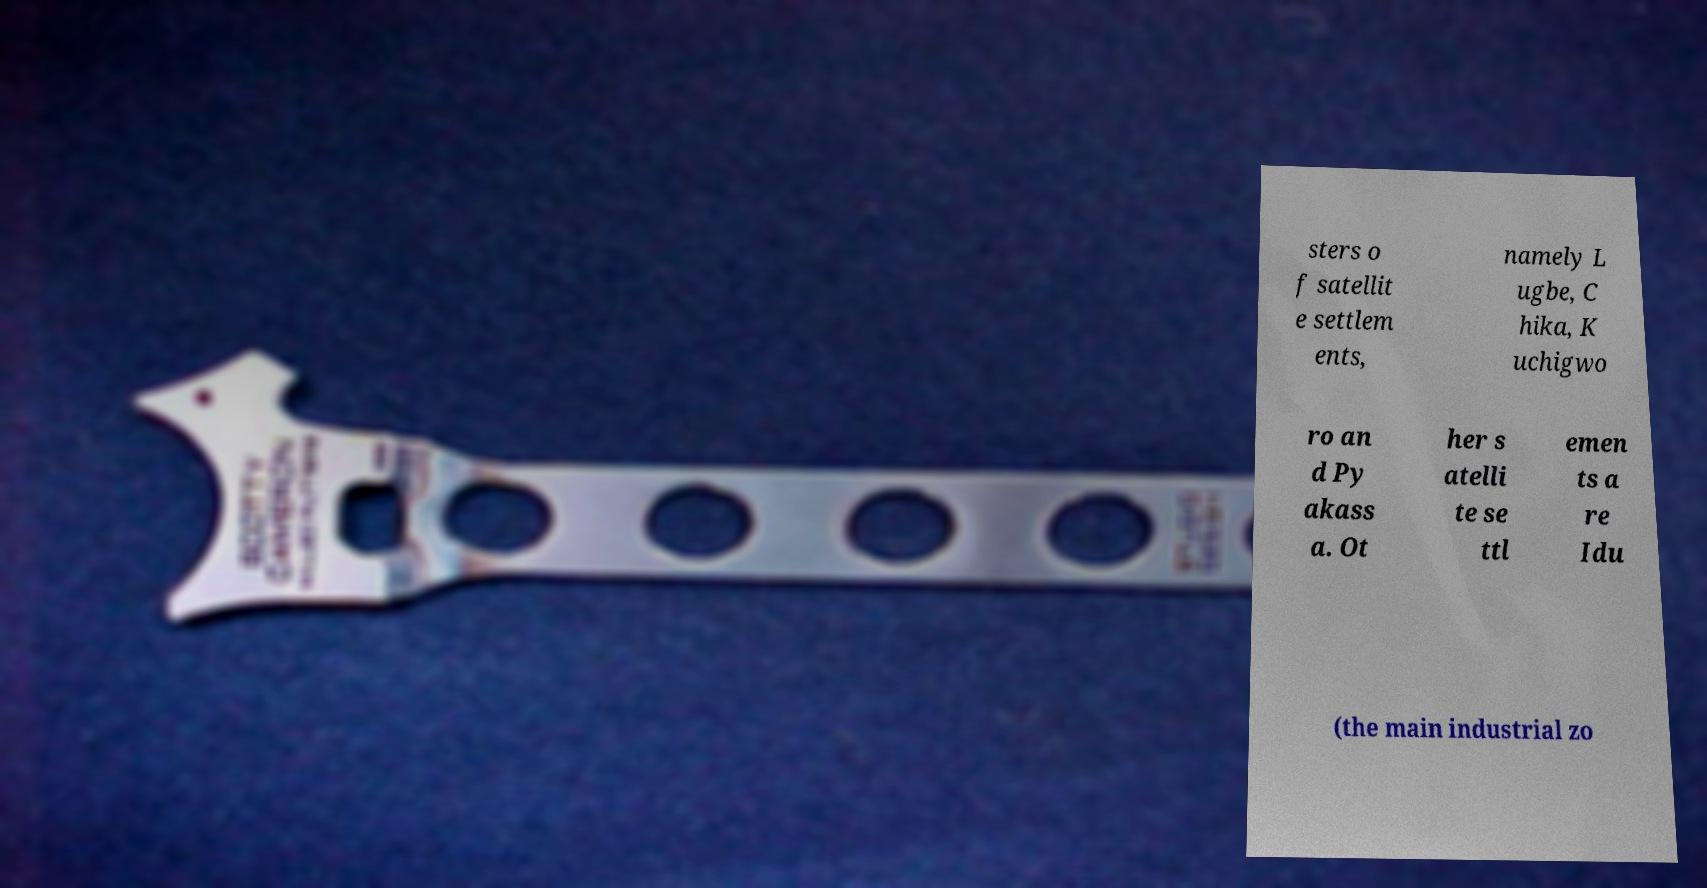Please identify and transcribe the text found in this image. sters o f satellit e settlem ents, namely L ugbe, C hika, K uchigwo ro an d Py akass a. Ot her s atelli te se ttl emen ts a re Idu (the main industrial zo 